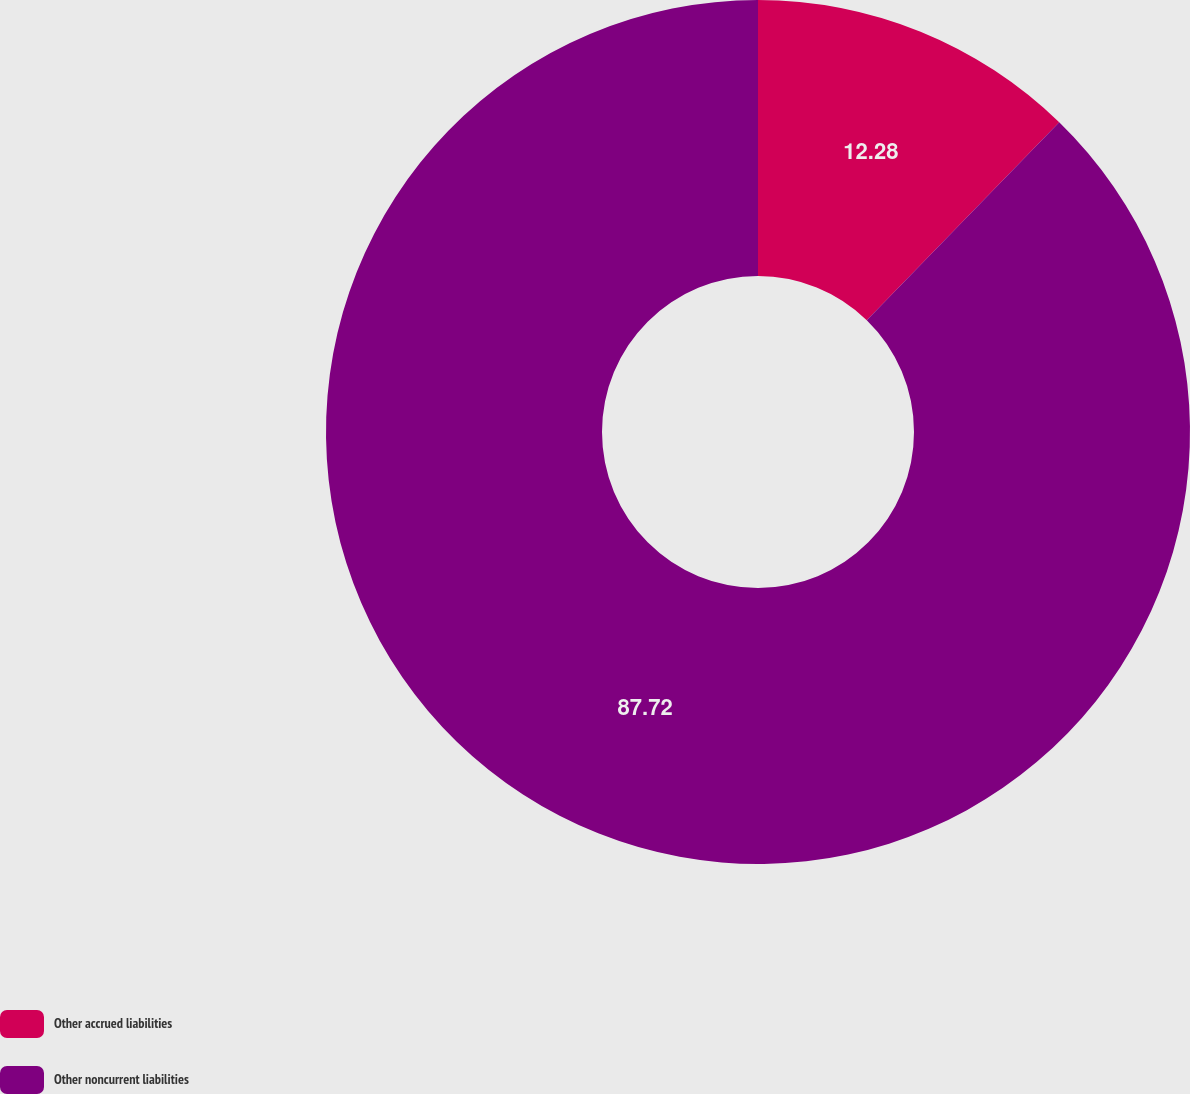Convert chart to OTSL. <chart><loc_0><loc_0><loc_500><loc_500><pie_chart><fcel>Other accrued liabilities<fcel>Other noncurrent liabilities<nl><fcel>12.28%<fcel>87.72%<nl></chart> 